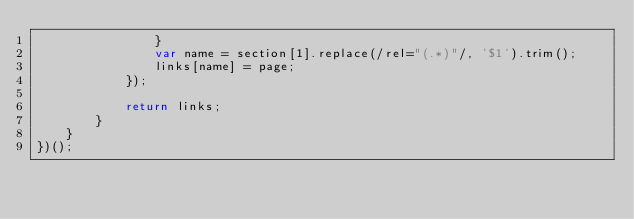Convert code to text. <code><loc_0><loc_0><loc_500><loc_500><_JavaScript_>                }
                var name = section[1].replace(/rel="(.*)"/, '$1').trim();
                links[name] = page;
            });

            return links;
        }
    }
})();
</code> 